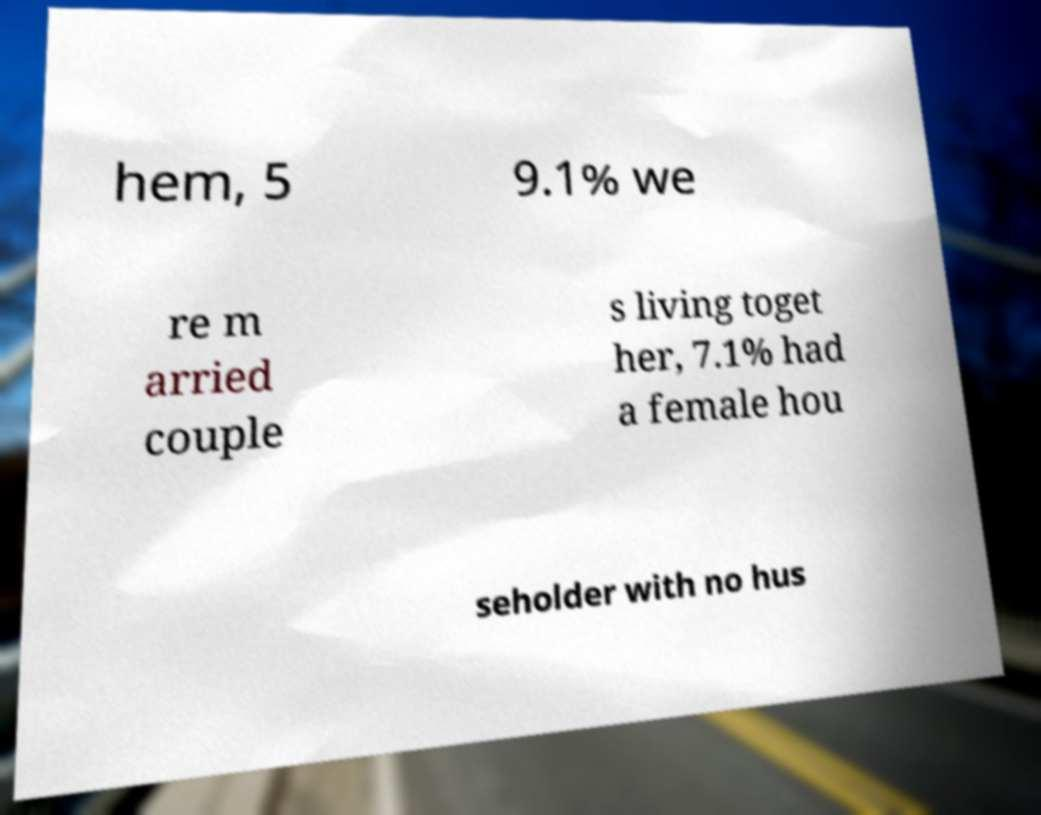Can you accurately transcribe the text from the provided image for me? hem, 5 9.1% we re m arried couple s living toget her, 7.1% had a female hou seholder with no hus 